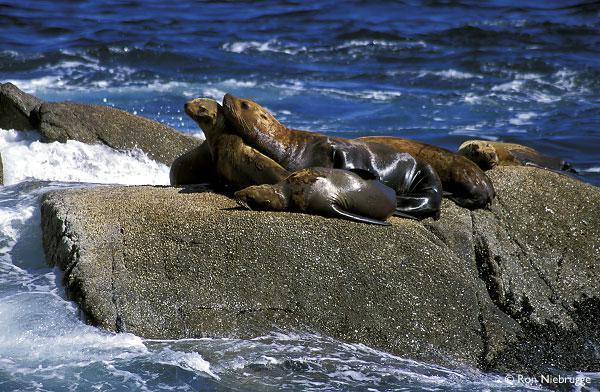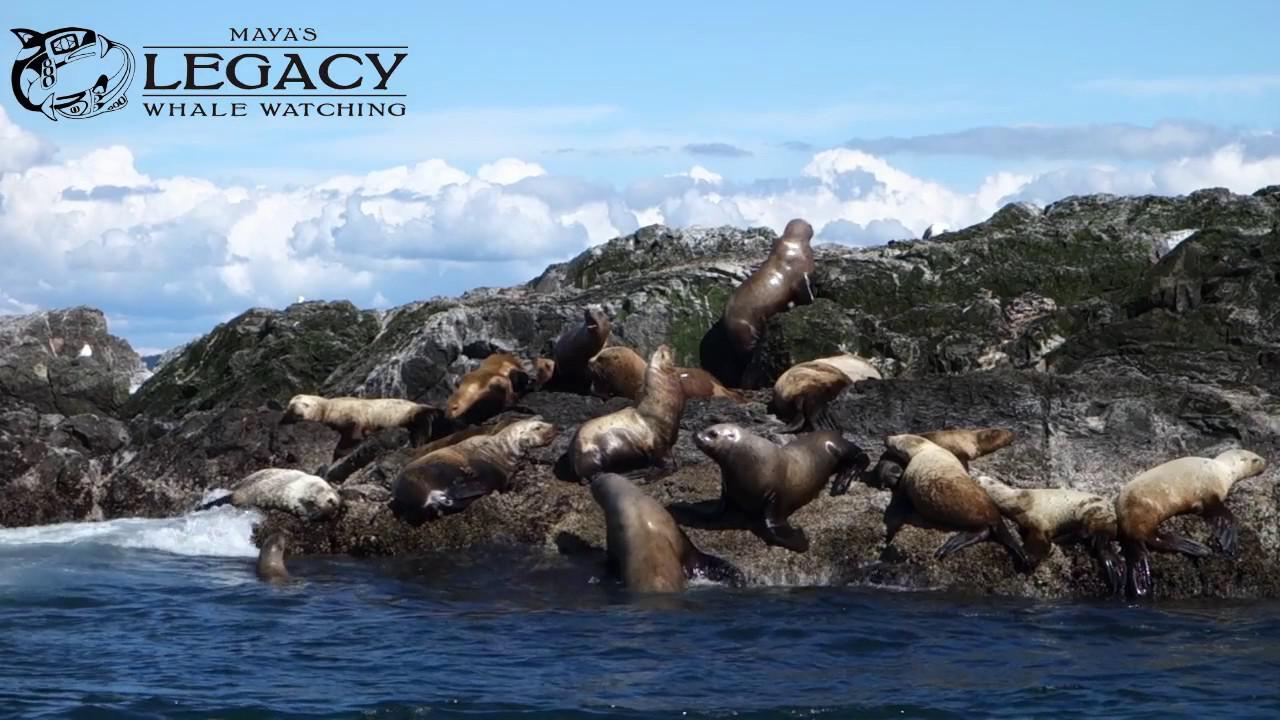The first image is the image on the left, the second image is the image on the right. Evaluate the accuracy of this statement regarding the images: "The left image contains exactly one sea lion.". Is it true? Answer yes or no. No. The first image is the image on the left, the second image is the image on the right. Assess this claim about the two images: "In each image, a large seal has its head and shoulders upright, and the upright seals in the left and right images face the same direction.". Correct or not? Answer yes or no. No. 